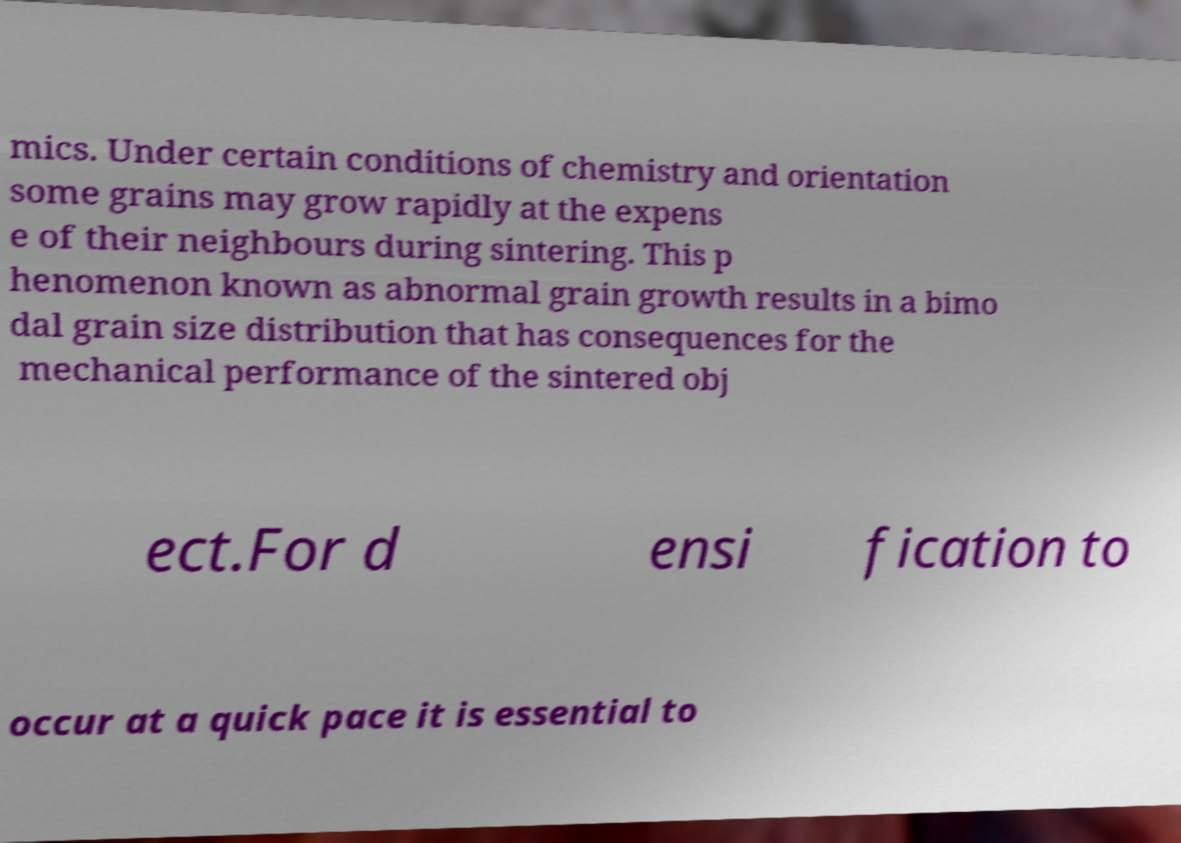For documentation purposes, I need the text within this image transcribed. Could you provide that? mics. Under certain conditions of chemistry and orientation some grains may grow rapidly at the expens e of their neighbours during sintering. This p henomenon known as abnormal grain growth results in a bimo dal grain size distribution that has consequences for the mechanical performance of the sintered obj ect.For d ensi fication to occur at a quick pace it is essential to 